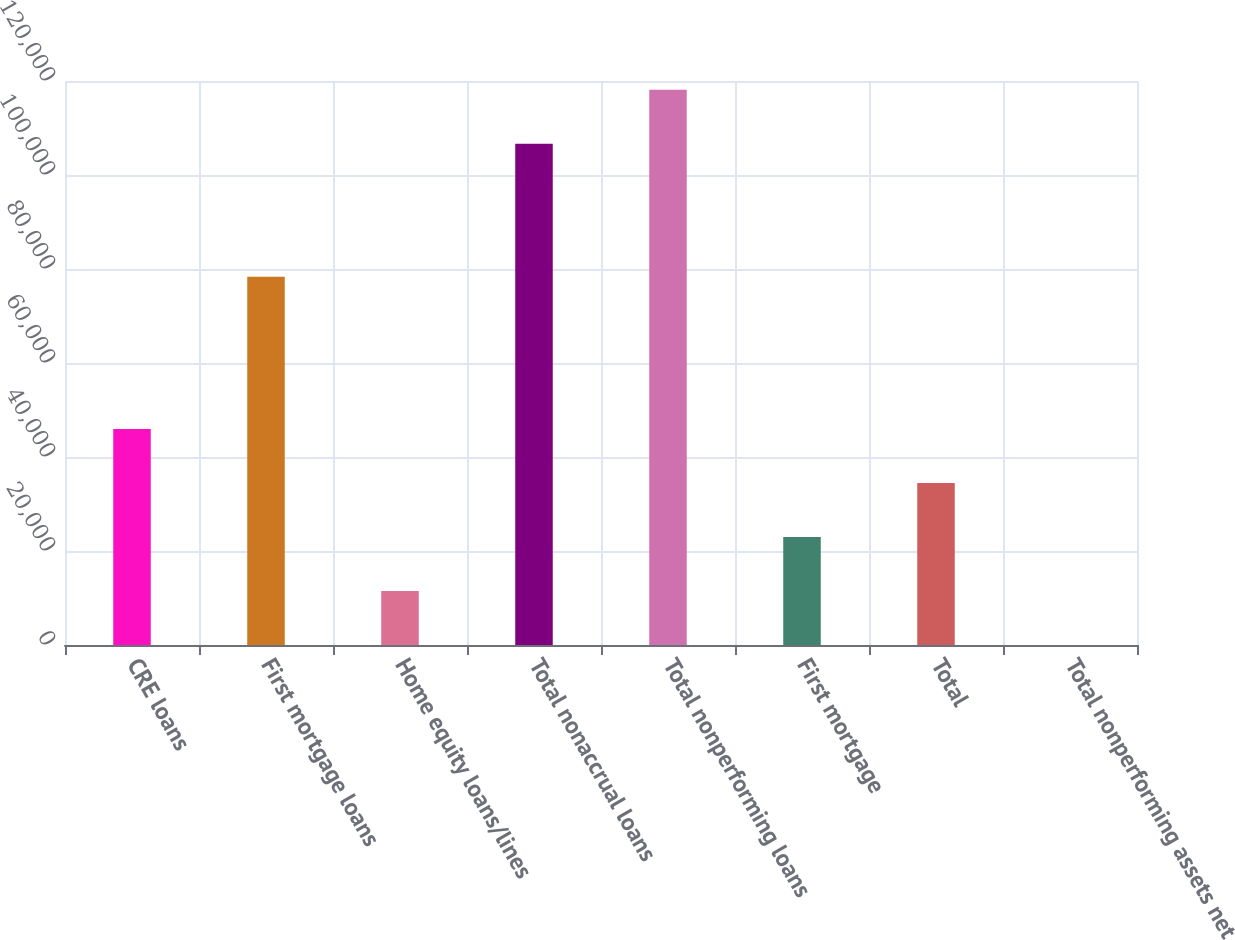Convert chart to OTSL. <chart><loc_0><loc_0><loc_500><loc_500><bar_chart><fcel>CRE loans<fcel>First mortgage loans<fcel>Home equity loans/lines<fcel>Total nonaccrual loans<fcel>Total nonperforming loans<fcel>First mortgage<fcel>Total<fcel>Total nonperforming assets net<nl><fcel>45951.9<fcel>78372<fcel>11488.9<fcel>106660<fcel>118148<fcel>22976.5<fcel>34464.2<fcel>1.18<nl></chart> 